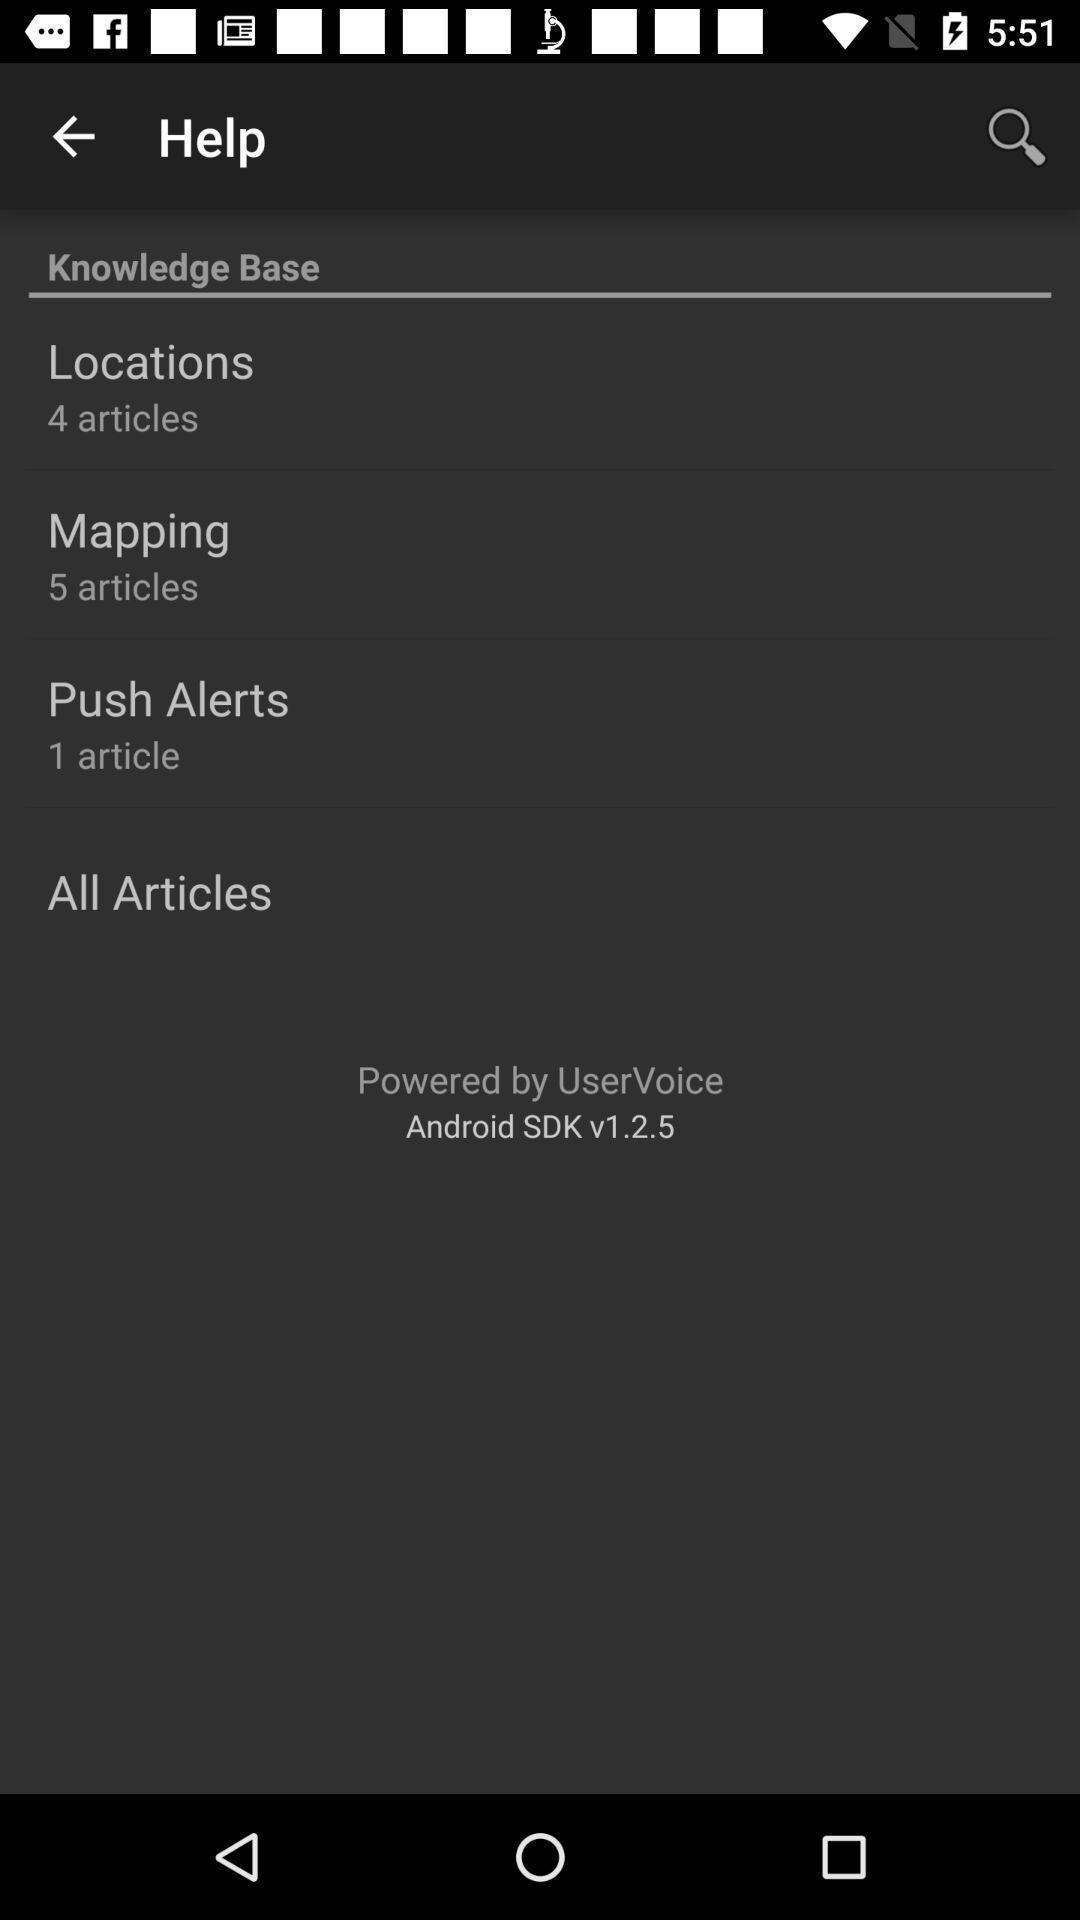Provide a detailed account of this screenshot. Screen showing help page. 